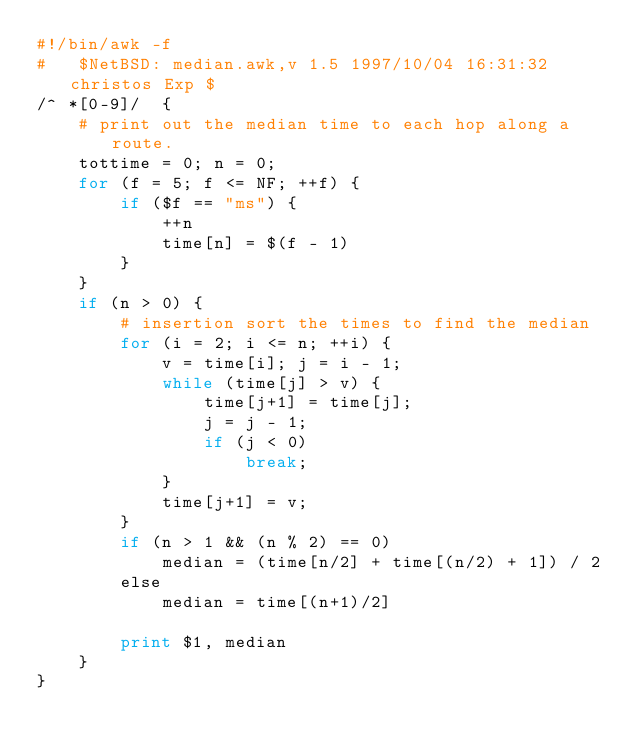Convert code to text. <code><loc_0><loc_0><loc_500><loc_500><_Awk_>#!/bin/awk -f
#	$NetBSD: median.awk,v 1.5 1997/10/04 16:31:32 christos Exp $
/^ *[0-9]/	{
	# print out the median time to each hop along a route.
	tottime = 0; n = 0;
	for (f = 5; f <= NF; ++f) {
		if ($f == "ms") {
			++n
			time[n] = $(f - 1)
		}
	}
	if (n > 0) {
		# insertion sort the times to find the median
		for (i = 2; i <= n; ++i) {
			v = time[i]; j = i - 1;
			while (time[j] > v) {
				time[j+1] = time[j];
				j = j - 1;
				if (j < 0)
					break;
			}
			time[j+1] = v;
		}
		if (n > 1 && (n % 2) == 0)
			median = (time[n/2] + time[(n/2) + 1]) / 2
		else
			median = time[(n+1)/2]

		print $1, median
	}
}
</code> 